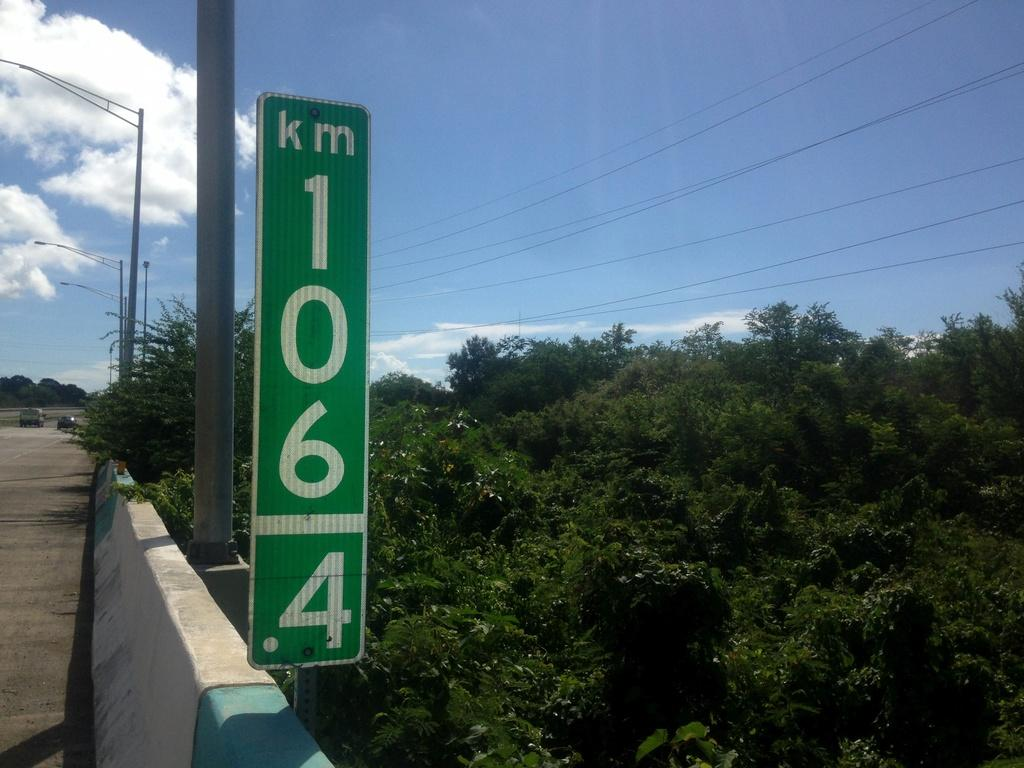What is the main object in the image? There is a sign board in the image. What other structures can be seen in the image? There are poles, trees, a wall, and a road in the image. Are there any vehicles in the image? Yes, there are vehicles in the image. What is visible in the background of the image? The background of the image includes the sky and wires. How many letters are on the bed in the image? There is no bed present in the image, and therefore no letters can be found on it. 